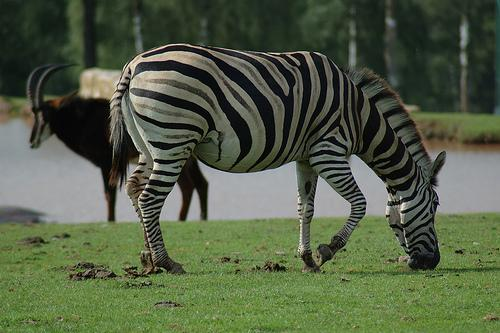What color is the grass and how does it appear? The grass is very green and appears to be neatly trimmed. What is the color of the secondary animal's horns and how are they shaped? The horns of the secondary animal, the ram, are black and have a curved shape. Describe the overall quality of the image and mention any prominent reason affecting its quality. The overall quality of the image is fairly good, but the sable antelope (ram) in the background appears blurry, affecting the image's sharpness. What is a particular feature of the zebra's appearance in the image? The zebra has black and white stripes, with some of its black stripes looking slightly faded or gray. State a fact about the environment and the time the photo was taken. The photo was taken during the day, and there's a muddy brown lake visible in the backdrop. Describe any two visible tree-related features in the image. There is a white spot on a tree and a wide gray base can also be seen on another tree. List three descriptions of the secondary animal in the background. The secondary animal is a ram that is dark brown in color and has two curved black horns. Mention how many animals are there in the image and explain their interaction. There are two animals in the image - a zebra and a ram. The zebra is in front, eating grass, while the ram is behind the zebra and slightly blurred. What sentiment could be associated with the image, given the animals' appearance? The sentiment could be described as serene or peaceful, as both animals seem to be calmly coexisting in their natural habitat. Identify the primary animal and its action in the image. The zebra is the main animal and it is eating grass in the wild. 